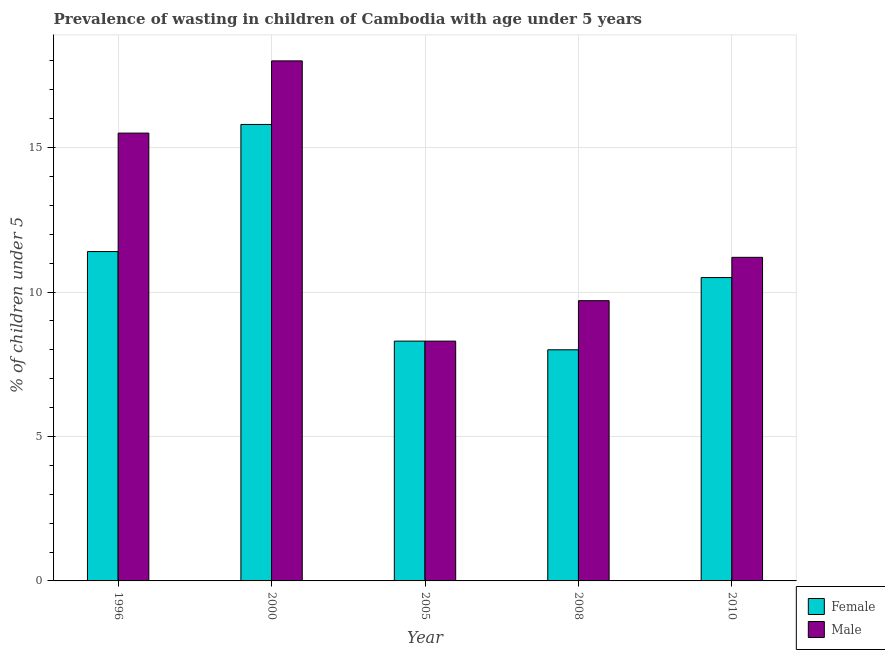How many different coloured bars are there?
Your response must be concise. 2. Are the number of bars on each tick of the X-axis equal?
Give a very brief answer. Yes. What is the label of the 4th group of bars from the left?
Your answer should be compact. 2008. Across all years, what is the maximum percentage of undernourished female children?
Keep it short and to the point. 15.8. Across all years, what is the minimum percentage of undernourished male children?
Your answer should be very brief. 8.3. In which year was the percentage of undernourished male children minimum?
Give a very brief answer. 2005. What is the total percentage of undernourished male children in the graph?
Your response must be concise. 62.7. What is the difference between the percentage of undernourished male children in 2005 and that in 2010?
Provide a short and direct response. -2.9. What is the difference between the percentage of undernourished male children in 2008 and the percentage of undernourished female children in 1996?
Ensure brevity in your answer.  -5.8. What is the average percentage of undernourished male children per year?
Ensure brevity in your answer.  12.54. In the year 2005, what is the difference between the percentage of undernourished male children and percentage of undernourished female children?
Provide a succinct answer. 0. What is the ratio of the percentage of undernourished female children in 2000 to that in 2010?
Provide a succinct answer. 1.5. Is the percentage of undernourished female children in 2005 less than that in 2008?
Your response must be concise. No. Is the difference between the percentage of undernourished male children in 1996 and 2005 greater than the difference between the percentage of undernourished female children in 1996 and 2005?
Provide a short and direct response. No. What is the difference between the highest and the second highest percentage of undernourished male children?
Keep it short and to the point. 2.5. What is the difference between the highest and the lowest percentage of undernourished male children?
Your answer should be compact. 9.7. In how many years, is the percentage of undernourished female children greater than the average percentage of undernourished female children taken over all years?
Provide a short and direct response. 2. Is the sum of the percentage of undernourished female children in 1996 and 2010 greater than the maximum percentage of undernourished male children across all years?
Your answer should be very brief. Yes. What does the 1st bar from the right in 1996 represents?
Provide a short and direct response. Male. How many bars are there?
Your answer should be very brief. 10. How many years are there in the graph?
Make the answer very short. 5. Where does the legend appear in the graph?
Provide a succinct answer. Bottom right. How are the legend labels stacked?
Your answer should be very brief. Vertical. What is the title of the graph?
Ensure brevity in your answer.  Prevalence of wasting in children of Cambodia with age under 5 years. Does "From human activities" appear as one of the legend labels in the graph?
Your answer should be very brief. No. What is the label or title of the X-axis?
Your answer should be very brief. Year. What is the label or title of the Y-axis?
Make the answer very short.  % of children under 5. What is the  % of children under 5 in Female in 1996?
Your response must be concise. 11.4. What is the  % of children under 5 in Female in 2000?
Your answer should be compact. 15.8. What is the  % of children under 5 in Female in 2005?
Make the answer very short. 8.3. What is the  % of children under 5 in Male in 2005?
Offer a terse response. 8.3. What is the  % of children under 5 of Male in 2008?
Keep it short and to the point. 9.7. What is the  % of children under 5 in Female in 2010?
Give a very brief answer. 10.5. What is the  % of children under 5 of Male in 2010?
Provide a succinct answer. 11.2. Across all years, what is the maximum  % of children under 5 in Female?
Your answer should be compact. 15.8. Across all years, what is the maximum  % of children under 5 in Male?
Provide a short and direct response. 18. Across all years, what is the minimum  % of children under 5 of Female?
Your answer should be compact. 8. Across all years, what is the minimum  % of children under 5 in Male?
Give a very brief answer. 8.3. What is the total  % of children under 5 in Male in the graph?
Make the answer very short. 62.7. What is the difference between the  % of children under 5 in Female in 1996 and that in 2000?
Provide a short and direct response. -4.4. What is the difference between the  % of children under 5 of Female in 1996 and that in 2005?
Offer a very short reply. 3.1. What is the difference between the  % of children under 5 in Male in 1996 and that in 2005?
Provide a succinct answer. 7.2. What is the difference between the  % of children under 5 of Male in 2000 and that in 2005?
Offer a very short reply. 9.7. What is the difference between the  % of children under 5 in Female in 2000 and that in 2008?
Your answer should be compact. 7.8. What is the difference between the  % of children under 5 in Male in 2000 and that in 2008?
Provide a short and direct response. 8.3. What is the difference between the  % of children under 5 in Female in 2005 and that in 2008?
Ensure brevity in your answer.  0.3. What is the difference between the  % of children under 5 of Female in 2005 and that in 2010?
Give a very brief answer. -2.2. What is the difference between the  % of children under 5 of Male in 2005 and that in 2010?
Provide a succinct answer. -2.9. What is the difference between the  % of children under 5 in Male in 2008 and that in 2010?
Provide a succinct answer. -1.5. What is the difference between the  % of children under 5 in Female in 1996 and the  % of children under 5 in Male in 2005?
Offer a very short reply. 3.1. What is the difference between the  % of children under 5 in Female in 1996 and the  % of children under 5 in Male in 2008?
Provide a succinct answer. 1.7. What is the difference between the  % of children under 5 in Female in 2000 and the  % of children under 5 in Male in 2005?
Keep it short and to the point. 7.5. What is the difference between the  % of children under 5 in Female in 2000 and the  % of children under 5 in Male in 2010?
Offer a very short reply. 4.6. What is the difference between the  % of children under 5 of Female in 2005 and the  % of children under 5 of Male in 2008?
Make the answer very short. -1.4. What is the difference between the  % of children under 5 of Female in 2005 and the  % of children under 5 of Male in 2010?
Provide a succinct answer. -2.9. What is the average  % of children under 5 in Female per year?
Provide a short and direct response. 10.8. What is the average  % of children under 5 of Male per year?
Your response must be concise. 12.54. In the year 1996, what is the difference between the  % of children under 5 in Female and  % of children under 5 in Male?
Provide a short and direct response. -4.1. In the year 2005, what is the difference between the  % of children under 5 in Female and  % of children under 5 in Male?
Ensure brevity in your answer.  0. In the year 2008, what is the difference between the  % of children under 5 in Female and  % of children under 5 in Male?
Provide a succinct answer. -1.7. What is the ratio of the  % of children under 5 in Female in 1996 to that in 2000?
Your response must be concise. 0.72. What is the ratio of the  % of children under 5 of Male in 1996 to that in 2000?
Your response must be concise. 0.86. What is the ratio of the  % of children under 5 in Female in 1996 to that in 2005?
Offer a very short reply. 1.37. What is the ratio of the  % of children under 5 in Male in 1996 to that in 2005?
Your answer should be compact. 1.87. What is the ratio of the  % of children under 5 of Female in 1996 to that in 2008?
Ensure brevity in your answer.  1.43. What is the ratio of the  % of children under 5 in Male in 1996 to that in 2008?
Make the answer very short. 1.6. What is the ratio of the  % of children under 5 in Female in 1996 to that in 2010?
Your response must be concise. 1.09. What is the ratio of the  % of children under 5 of Male in 1996 to that in 2010?
Make the answer very short. 1.38. What is the ratio of the  % of children under 5 in Female in 2000 to that in 2005?
Your answer should be very brief. 1.9. What is the ratio of the  % of children under 5 in Male in 2000 to that in 2005?
Your response must be concise. 2.17. What is the ratio of the  % of children under 5 of Female in 2000 to that in 2008?
Your answer should be very brief. 1.98. What is the ratio of the  % of children under 5 in Male in 2000 to that in 2008?
Offer a very short reply. 1.86. What is the ratio of the  % of children under 5 in Female in 2000 to that in 2010?
Your answer should be compact. 1.5. What is the ratio of the  % of children under 5 in Male in 2000 to that in 2010?
Give a very brief answer. 1.61. What is the ratio of the  % of children under 5 of Female in 2005 to that in 2008?
Give a very brief answer. 1.04. What is the ratio of the  % of children under 5 of Male in 2005 to that in 2008?
Provide a short and direct response. 0.86. What is the ratio of the  % of children under 5 in Female in 2005 to that in 2010?
Your answer should be compact. 0.79. What is the ratio of the  % of children under 5 of Male in 2005 to that in 2010?
Offer a terse response. 0.74. What is the ratio of the  % of children under 5 in Female in 2008 to that in 2010?
Give a very brief answer. 0.76. What is the ratio of the  % of children under 5 of Male in 2008 to that in 2010?
Ensure brevity in your answer.  0.87. What is the difference between the highest and the second highest  % of children under 5 in Male?
Offer a very short reply. 2.5. What is the difference between the highest and the lowest  % of children under 5 of Male?
Give a very brief answer. 9.7. 